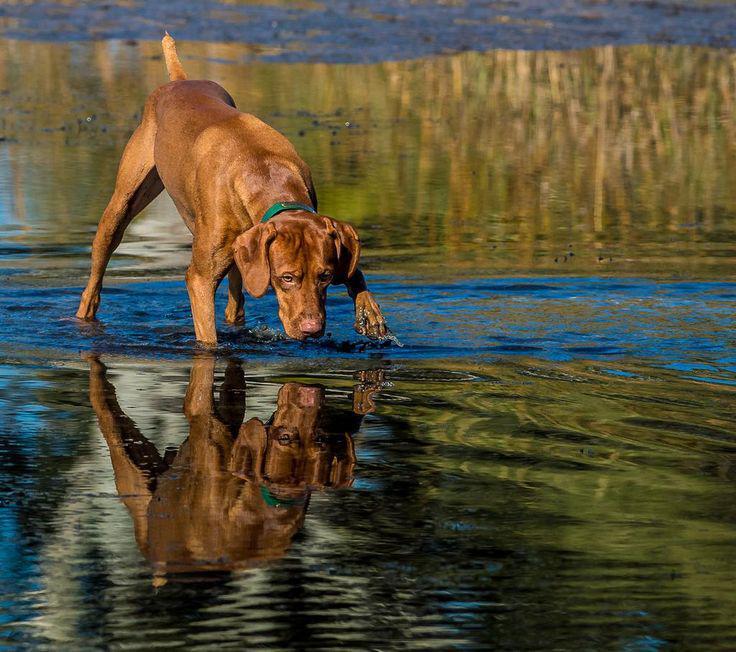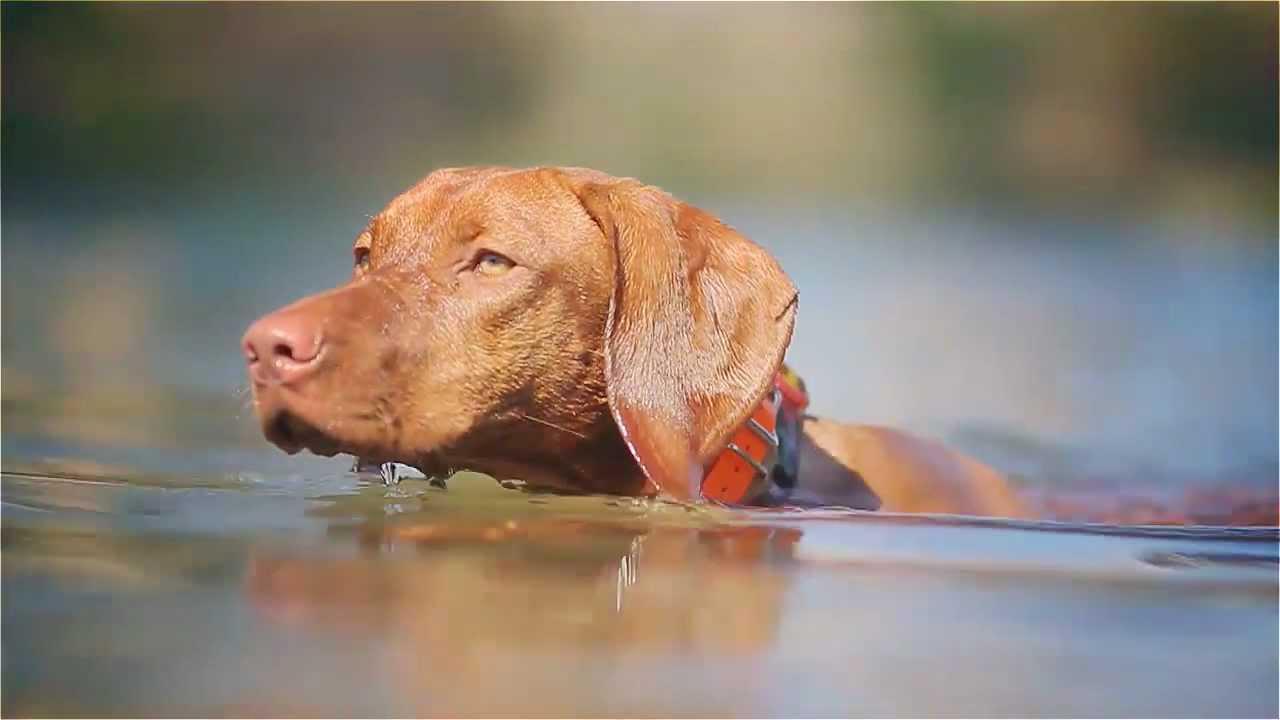The first image is the image on the left, the second image is the image on the right. For the images displayed, is the sentence "One image shows a red-orange dog standing in profile with its head upright, tail outstretched, and a front paw raised and bent inward." factually correct? Answer yes or no. No. 